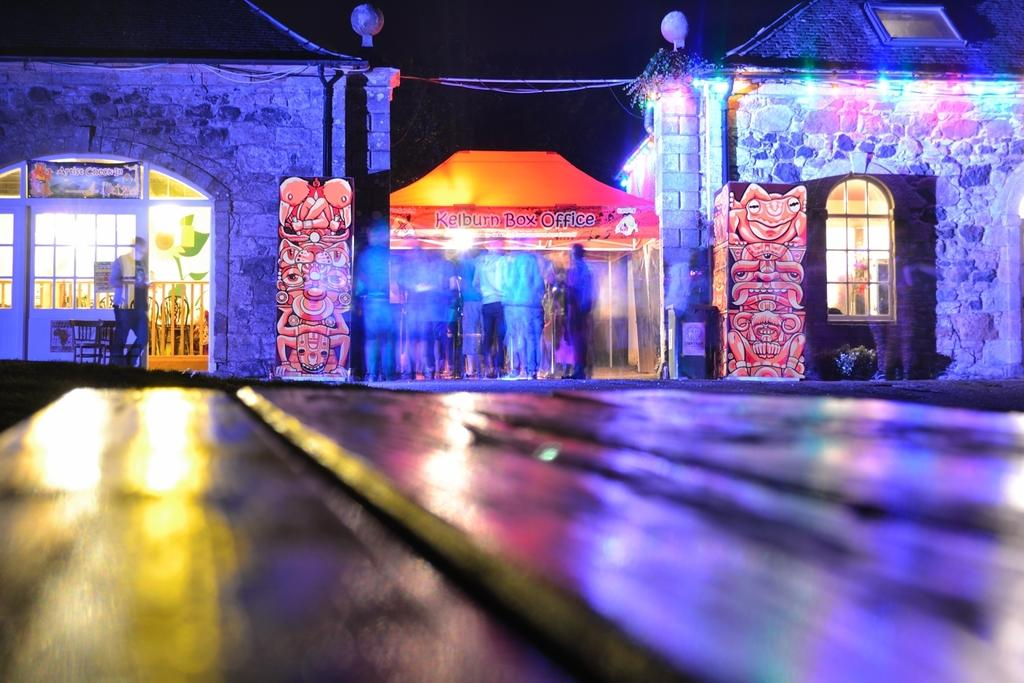How many people are present in the image? There are few persons in the image. What type of structures can be seen in the image? There are buildings in the image. What architectural features are visible in the image? There are windows, doors, and lights visible in the image. What type of signage is present in the image? There are hoardings and boards in the image. What is visible in the background of the image? The sky is visible in the background of the image. What type of fruit is hanging from the hoardings in the image? There is no fruit hanging from the hoardings in the image; only signage is present. What type of silk material is draped over the buildings in the image? There is no silk material draped over the buildings in the image; only solid structures are visible. 